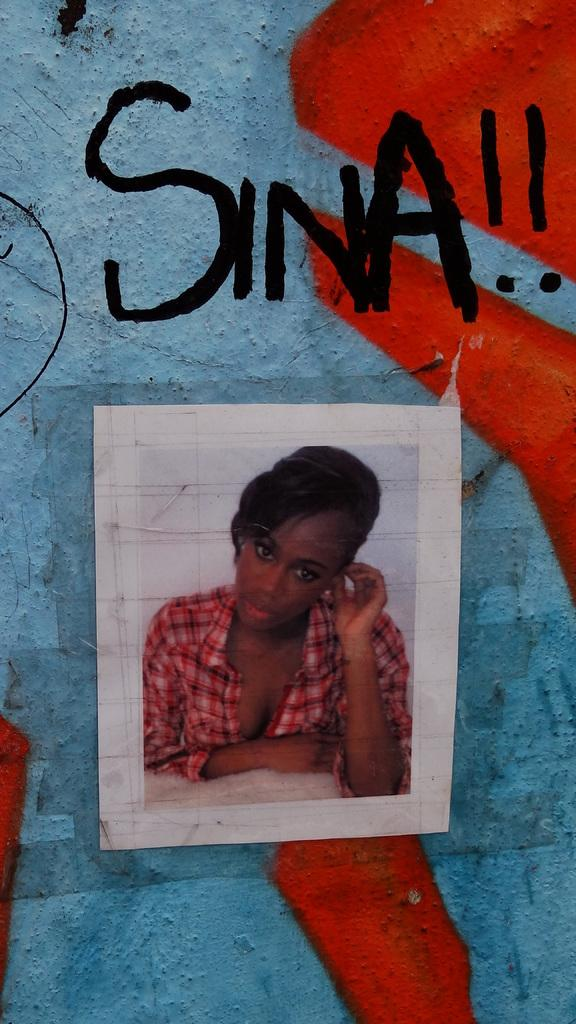What is the main subject of the image? There is a photo of a lady in the image. What is the lady wearing in the photo? The lady is wearing a red shirt in the photo. How is the photo displayed in the image? The photo is on a paper, and the paper is on the wall. What finger does the lady use to point at the society in the image? There is no society or finger pointing in the image; it only features a photo of a lady wearing a red shirt on a paper that is on the wall. 